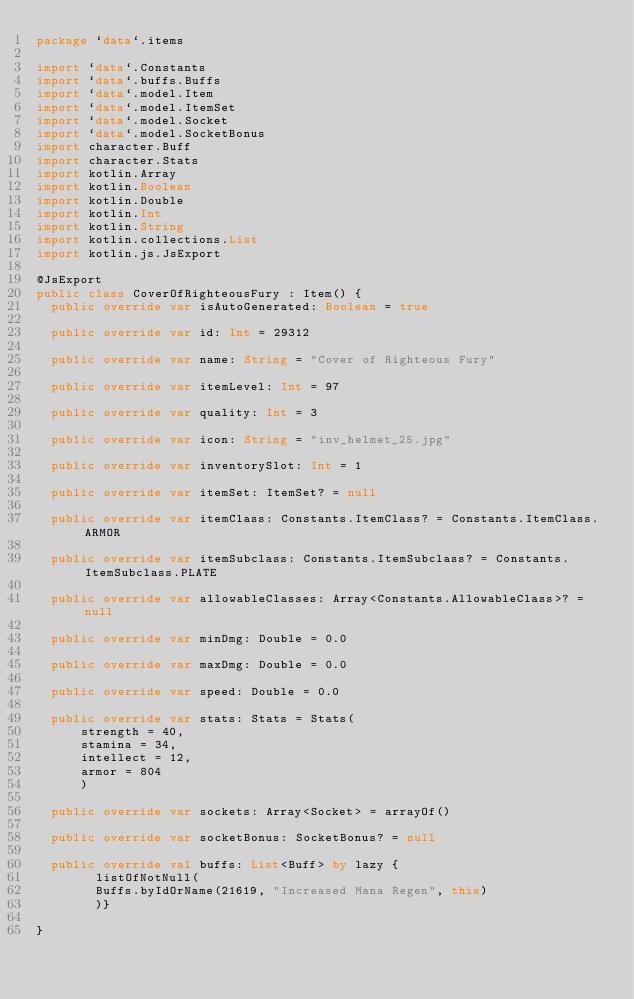<code> <loc_0><loc_0><loc_500><loc_500><_Kotlin_>package `data`.items

import `data`.Constants
import `data`.buffs.Buffs
import `data`.model.Item
import `data`.model.ItemSet
import `data`.model.Socket
import `data`.model.SocketBonus
import character.Buff
import character.Stats
import kotlin.Array
import kotlin.Boolean
import kotlin.Double
import kotlin.Int
import kotlin.String
import kotlin.collections.List
import kotlin.js.JsExport

@JsExport
public class CoverOfRighteousFury : Item() {
  public override var isAutoGenerated: Boolean = true

  public override var id: Int = 29312

  public override var name: String = "Cover of Righteous Fury"

  public override var itemLevel: Int = 97

  public override var quality: Int = 3

  public override var icon: String = "inv_helmet_25.jpg"

  public override var inventorySlot: Int = 1

  public override var itemSet: ItemSet? = null

  public override var itemClass: Constants.ItemClass? = Constants.ItemClass.ARMOR

  public override var itemSubclass: Constants.ItemSubclass? = Constants.ItemSubclass.PLATE

  public override var allowableClasses: Array<Constants.AllowableClass>? = null

  public override var minDmg: Double = 0.0

  public override var maxDmg: Double = 0.0

  public override var speed: Double = 0.0

  public override var stats: Stats = Stats(
      strength = 40,
      stamina = 34,
      intellect = 12,
      armor = 804
      )

  public override var sockets: Array<Socket> = arrayOf()

  public override var socketBonus: SocketBonus? = null

  public override val buffs: List<Buff> by lazy {
        listOfNotNull(
        Buffs.byIdOrName(21619, "Increased Mana Regen", this)
        )}

}
</code> 